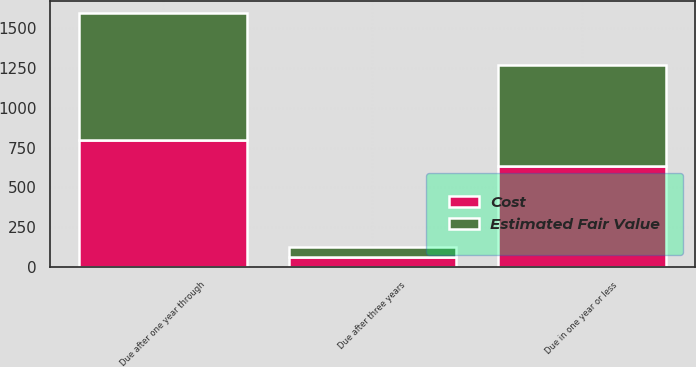Convert chart. <chart><loc_0><loc_0><loc_500><loc_500><stacked_bar_chart><ecel><fcel>Due in one year or less<fcel>Due after one year through<fcel>Due after three years<nl><fcel>Cost<fcel>633.6<fcel>797.3<fcel>63.1<nl><fcel>Estimated Fair Value<fcel>635.3<fcel>797<fcel>62.2<nl></chart> 